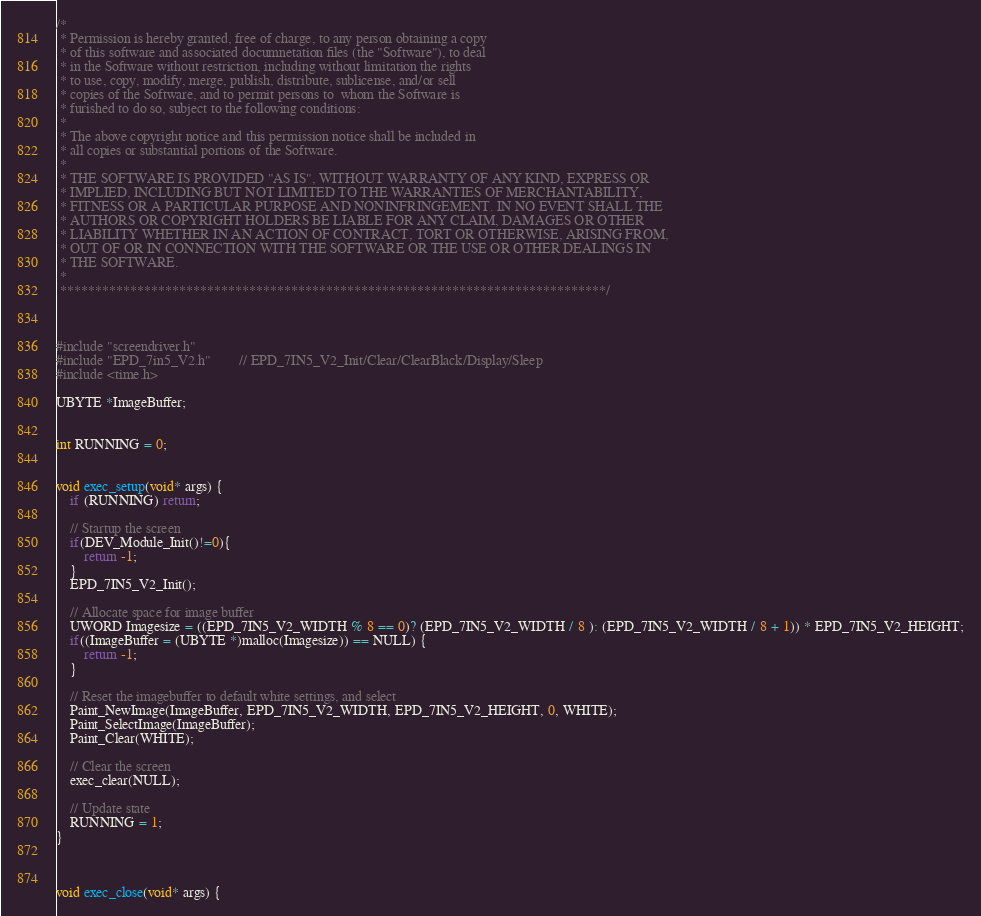<code> <loc_0><loc_0><loc_500><loc_500><_C_>/*
 * Permission is hereby granted, free of charge, to any person obtaining a copy
 * of this software and associated documnetation files (the "Software"), to deal
 * in the Software without restriction, including without limitation the rights
 * to use, copy, modify, merge, publish, distribute, sublicense, and/or sell
 * copies of the Software, and to permit persons to  whom the Software is
 * furished to do so, subject to the following conditions:
 *
 * The above copyright notice and this permission notice shall be included in
 * all copies or substantial portions of the Software.
 *
 * THE SOFTWARE IS PROVIDED "AS IS", WITHOUT WARRANTY OF ANY KIND, EXPRESS OR
 * IMPLIED, INCLUDING BUT NOT LIMITED TO THE WARRANTIES OF MERCHANTABILITY,
 * FITNESS OR A PARTICULAR PURPOSE AND NONINFRINGEMENT. IN NO EVENT SHALL THE
 * AUTHORS OR COPYRIGHT HOLDERS BE LIABLE FOR ANY CLAIM, DAMAGES OR OTHER
 * LIABILITY WHETHER IN AN ACTION OF CONTRACT, TORT OR OTHERWISE, ARISING FROM,
 * OUT OF OR IN CONNECTION WITH THE SOFTWARE OR THE USE OR OTHER DEALINGS IN
 * THE SOFTWARE.
 *
 ******************************************************************************/



#include "screendriver.h"		
#include "EPD_7in5_V2.h"		// EPD_7IN5_V2_Init/Clear/ClearBlack/Display/Sleep
#include <time.h> 

UBYTE *ImageBuffer;


int RUNNING = 0;


void exec_setup(void* args) {
	if (RUNNING) return;

	// Startup the screen
	if(DEV_Module_Init()!=0){
        return -1;
    }
    EPD_7IN5_V2_Init();
	
	// Allocate space for image buffer	
	UWORD Imagesize = ((EPD_7IN5_V2_WIDTH % 8 == 0)? (EPD_7IN5_V2_WIDTH / 8 ): (EPD_7IN5_V2_WIDTH / 8 + 1)) * EPD_7IN5_V2_HEIGHT;
    if((ImageBuffer = (UBYTE *)malloc(Imagesize)) == NULL) {
        return -1;
    }
	
	// Reset the imagebuffer to default white settings, and select
    Paint_NewImage(ImageBuffer, EPD_7IN5_V2_WIDTH, EPD_7IN5_V2_HEIGHT, 0, WHITE);
    Paint_SelectImage(ImageBuffer);
    Paint_Clear(WHITE);

	// Clear the screen
	exec_clear(NULL);
		
	// Update state
	RUNNING = 1;
}



void exec_close(void* args) {</code> 